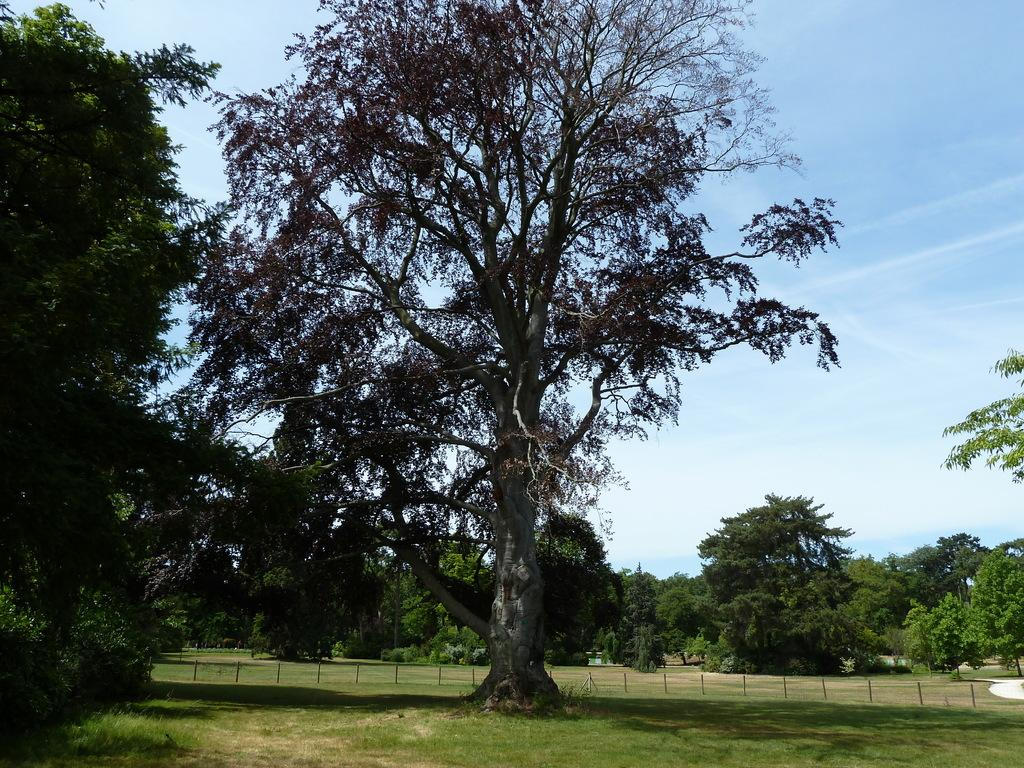What type of vegetation is present in the image? There is grass in the image. What other natural elements can be seen in the image? There are trees in the image. What man-made objects are visible in the image? There are wooden poles in the image. What can be seen in the background of the image? The sky is visible in the background of the image. What type of brass instrument is being played in the image? There is no brass instrument or any indication of music being played in the image. How does the fog affect the visibility of the trees in the image? There is no fog present in the image; the trees are clearly visible. 